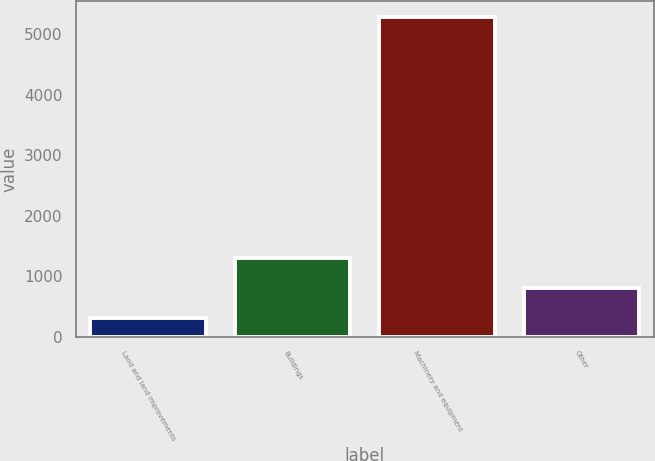<chart> <loc_0><loc_0><loc_500><loc_500><bar_chart><fcel>Land and land improvements<fcel>Buildings<fcel>Machinery and equipment<fcel>Other<nl><fcel>309<fcel>1301.8<fcel>5273<fcel>805.4<nl></chart> 